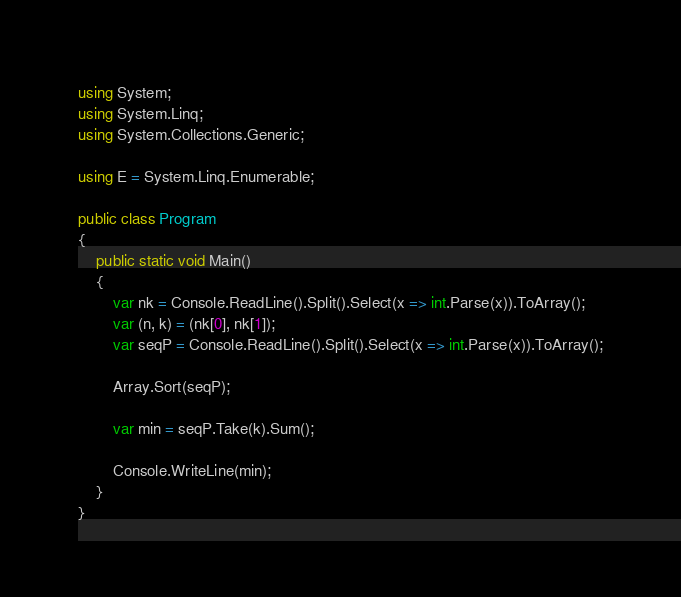<code> <loc_0><loc_0><loc_500><loc_500><_C#_>using System;
using System.Linq;
using System.Collections.Generic;

using E = System.Linq.Enumerable;

public class Program
{
    public static void Main()
    {
        var nk = Console.ReadLine().Split().Select(x => int.Parse(x)).ToArray();
        var (n, k) = (nk[0], nk[1]);
        var seqP = Console.ReadLine().Split().Select(x => int.Parse(x)).ToArray();

        Array.Sort(seqP);

        var min = seqP.Take(k).Sum();

        Console.WriteLine(min);
    }
}
</code> 